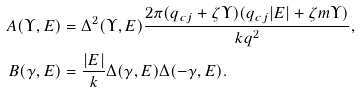Convert formula to latex. <formula><loc_0><loc_0><loc_500><loc_500>A ( \Upsilon , E ) & = \Delta ^ { 2 } ( \Upsilon , E ) \frac { 2 \pi ( q _ { c j } + \zeta \Upsilon ) ( q _ { c j } | E | + \zeta m \Upsilon ) } { k q ^ { 2 } } , \\ B ( \gamma , E ) & = \frac { | E | } { k } \Delta ( \gamma , E ) \Delta ( - \gamma , E ) .</formula> 